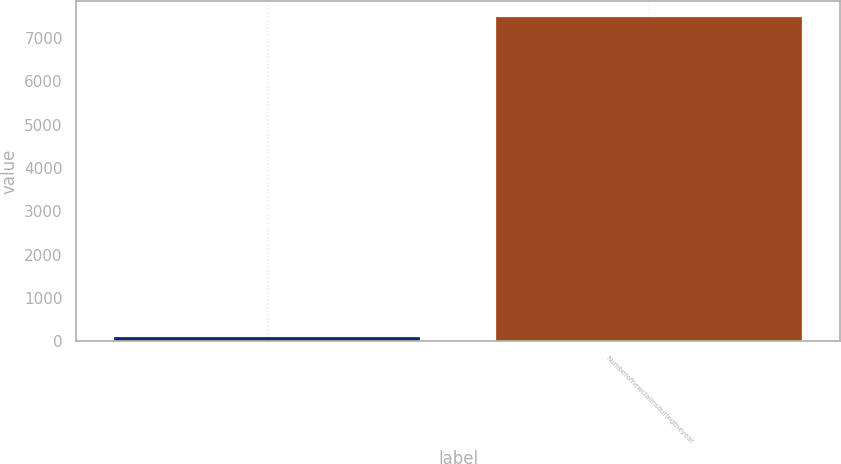Convert chart to OTSL. <chart><loc_0><loc_0><loc_500><loc_500><bar_chart><ecel><fcel>Numberofnewclaimsduringtheyear<nl><fcel>99<fcel>7491.8<nl></chart> 